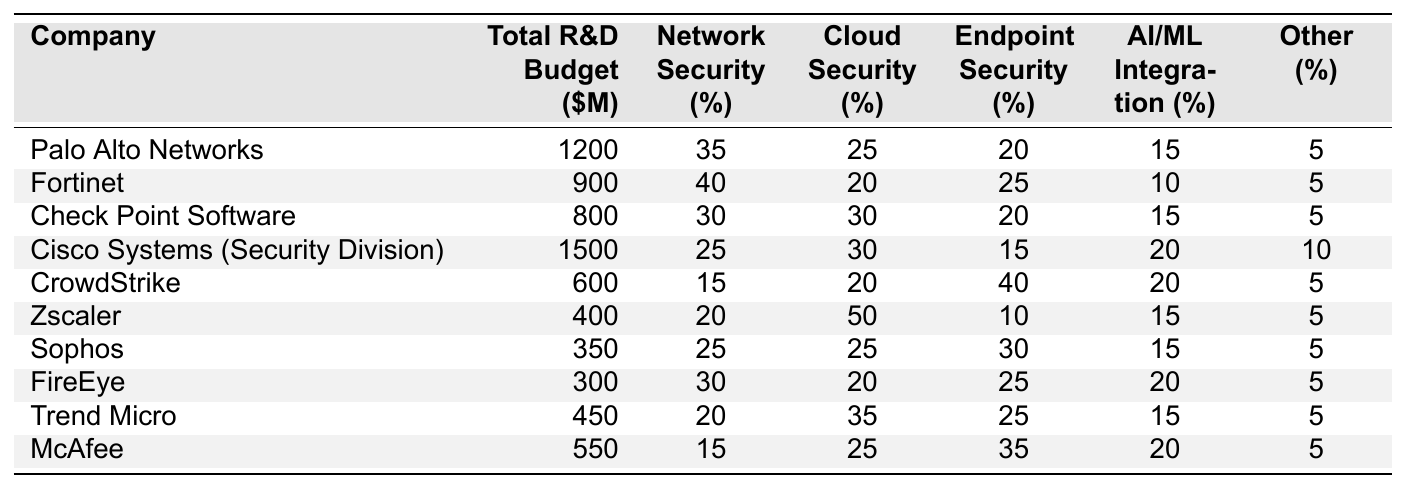What is the total R&D budget for Palo Alto Networks? The table lists Palo Alto Networks with a total R&D budget of 1200 million dollars.
Answer: 1200 million dollars Which company has the highest percentage allocated to AI/ML integration? The table shows that Cisco Systems (Security Division) allocates 20% to AI/ML integration, which is the highest percentage among the listed companies.
Answer: Cisco Systems (Security Division) What percentage of Fortinet's R&D budget is allocated to Network Security? Fortinet is shown to allocate 40% of its R&D budget to Network Security according to the table.
Answer: 40% Which company has the lowest total R&D budget? The table indicates that FireEye has the lowest total R&D budget at 300 million dollars.
Answer: FireEye What is the average percentage allocation for Cloud Security across all companies? To calculate the average, sum the percentages allocated to Cloud Security (25 + 20 + 30 + 30 + 20 + 50 + 25 + 20 + 35 + 25 =  255) and divide by the number of companies (10). Thus, the average is 255/10 = 25.5%.
Answer: 25.5% Which company's Endpoint Security percentage is greater than its Cloud Security percentage? Looking at the table, CrowdStrike allocates 40% to Endpoint Security while only 20% to Cloud Security, meeting the criteria.
Answer: CrowdStrike How much more does Cisco Systems allocate to Cloud Security compared to Network Security? Cisco Systems allocates 30% to Cloud Security and 25% to Network Security. The difference is 30 - 25 = 5%.
Answer: 5% Is Zscaler's total R&D budget larger than that of Sophos? Zscaler has a total R&D budget of 400 million dollars, while Sophos has 350 million dollars, making Zscaler's budget larger.
Answer: Yes Which companies allocate more than 10% of their budget to Other categories? The table shows that all companies have at least 5% allocated to Other categories, but only Cisco Systems (10%), CrowdStrike (5%), and others do not exceed 10%. The companies that exceed 10% are Palo Alto Networks, Fortinet, Check Point Software, Cisco Systems, CrowdStrike, Sophos, and Trend Micro.
Answer: Palo Alto Networks, Fortinet, Check Point Software What is the total percentage allocated to Cloud Security for all companies combined? The total percentages for Cloud Security are: 25 + 20 + 30 + 30 + 20 + 50 + 25 + 20 + 35 + 25 =  255%.
Answer: 255% 